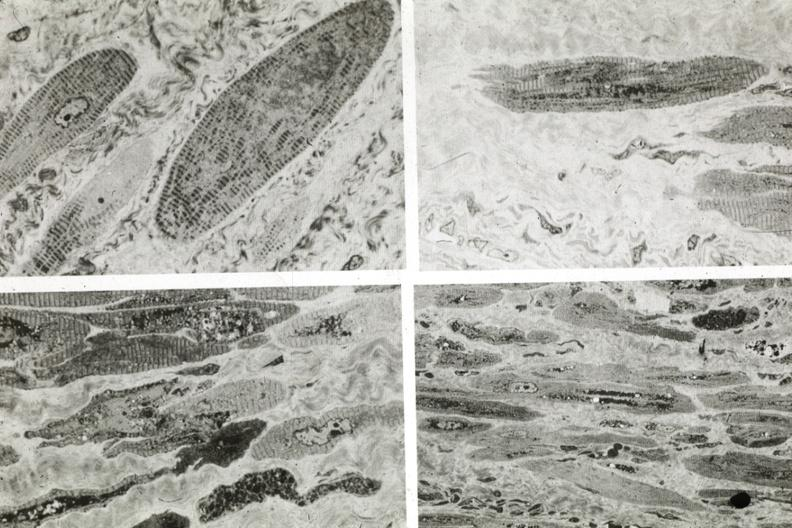s cardiovascular present?
Answer the question using a single word or phrase. Yes 